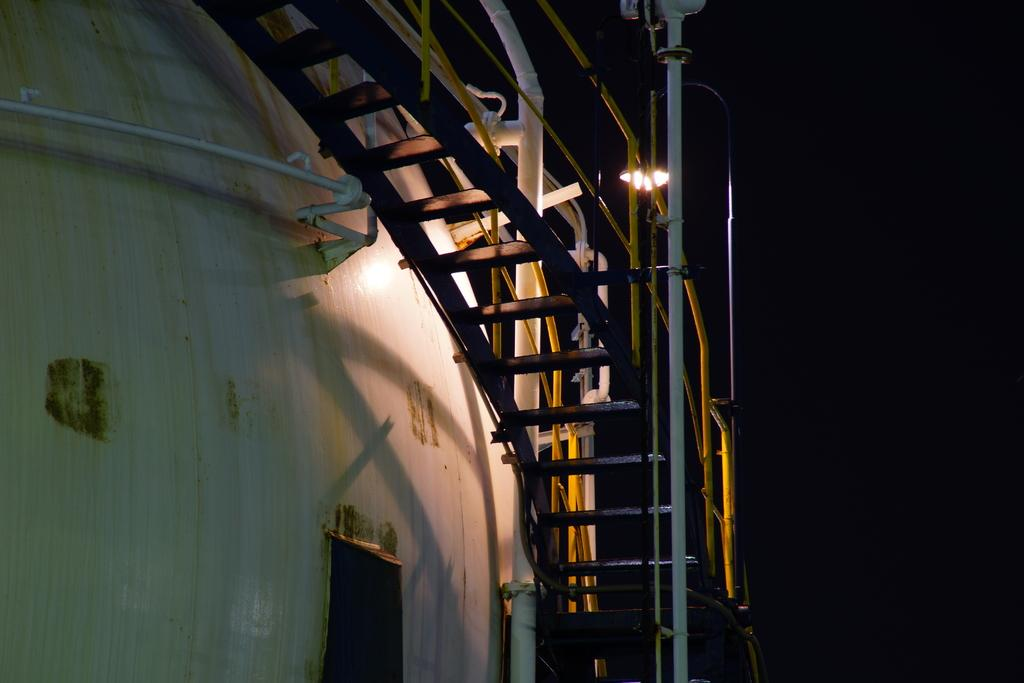What type of objects can be seen in the image? There are metal objects and rods in the image. Are there any other items visible besides the metal objects and rods? Yes, there are other items in the image. What can be observed about the background of the image? The background of the image is dark. How many kittens are playing in the dirt on the island in the image? There are no kittens, dirt, or island present in the image. 